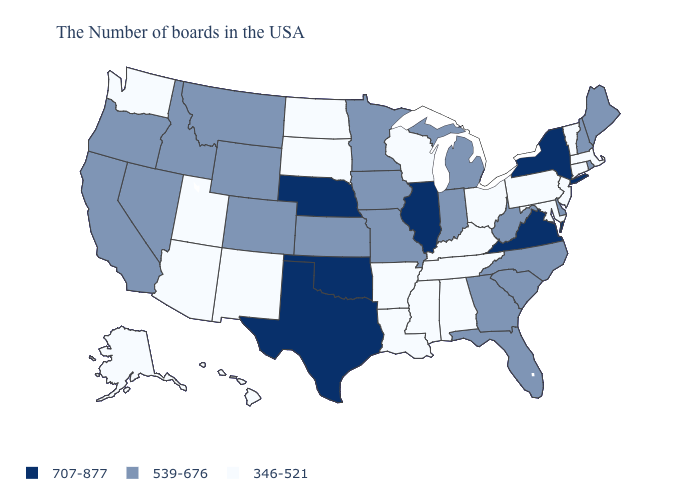Does Connecticut have a lower value than Illinois?
Keep it brief. Yes. Does the map have missing data?
Concise answer only. No. Name the states that have a value in the range 346-521?
Give a very brief answer. Massachusetts, Vermont, Connecticut, New Jersey, Maryland, Pennsylvania, Ohio, Kentucky, Alabama, Tennessee, Wisconsin, Mississippi, Louisiana, Arkansas, South Dakota, North Dakota, New Mexico, Utah, Arizona, Washington, Alaska, Hawaii. What is the value of Montana?
Give a very brief answer. 539-676. Name the states that have a value in the range 539-676?
Keep it brief. Maine, Rhode Island, New Hampshire, Delaware, North Carolina, South Carolina, West Virginia, Florida, Georgia, Michigan, Indiana, Missouri, Minnesota, Iowa, Kansas, Wyoming, Colorado, Montana, Idaho, Nevada, California, Oregon. Which states have the lowest value in the USA?
Write a very short answer. Massachusetts, Vermont, Connecticut, New Jersey, Maryland, Pennsylvania, Ohio, Kentucky, Alabama, Tennessee, Wisconsin, Mississippi, Louisiana, Arkansas, South Dakota, North Dakota, New Mexico, Utah, Arizona, Washington, Alaska, Hawaii. What is the value of California?
Short answer required. 539-676. Does Oregon have the lowest value in the USA?
Be succinct. No. Which states have the lowest value in the MidWest?
Quick response, please. Ohio, Wisconsin, South Dakota, North Dakota. What is the value of Idaho?
Keep it brief. 539-676. Does Virginia have the highest value in the South?
Short answer required. Yes. What is the value of Massachusetts?
Write a very short answer. 346-521. Which states have the lowest value in the USA?
Keep it brief. Massachusetts, Vermont, Connecticut, New Jersey, Maryland, Pennsylvania, Ohio, Kentucky, Alabama, Tennessee, Wisconsin, Mississippi, Louisiana, Arkansas, South Dakota, North Dakota, New Mexico, Utah, Arizona, Washington, Alaska, Hawaii. Among the states that border North Carolina , which have the lowest value?
Be succinct. Tennessee. Does Alaska have a lower value than Maryland?
Short answer required. No. 